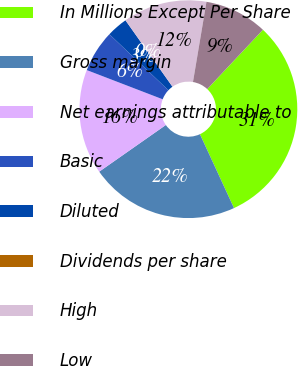Convert chart. <chart><loc_0><loc_0><loc_500><loc_500><pie_chart><fcel>In Millions Except Per Share<fcel>Gross margin<fcel>Net earnings attributable to<fcel>Basic<fcel>Diluted<fcel>Dividends per share<fcel>High<fcel>Low<nl><fcel>31.13%<fcel>22.15%<fcel>15.57%<fcel>6.23%<fcel>3.12%<fcel>0.0%<fcel>12.46%<fcel>9.34%<nl></chart> 